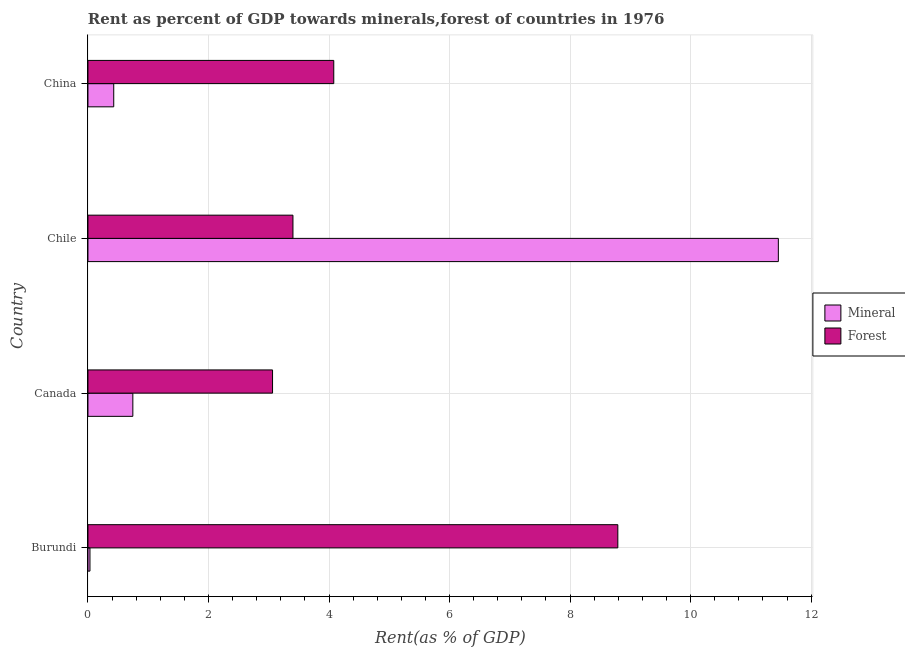How many different coloured bars are there?
Ensure brevity in your answer.  2. How many groups of bars are there?
Ensure brevity in your answer.  4. Are the number of bars per tick equal to the number of legend labels?
Keep it short and to the point. Yes. Are the number of bars on each tick of the Y-axis equal?
Your response must be concise. Yes. How many bars are there on the 2nd tick from the top?
Your response must be concise. 2. What is the label of the 3rd group of bars from the top?
Offer a terse response. Canada. What is the forest rent in Chile?
Your answer should be compact. 3.4. Across all countries, what is the maximum forest rent?
Make the answer very short. 8.79. Across all countries, what is the minimum forest rent?
Offer a terse response. 3.06. In which country was the mineral rent maximum?
Your answer should be very brief. Chile. What is the total mineral rent in the graph?
Your answer should be compact. 12.66. What is the difference between the mineral rent in Burundi and that in China?
Offer a terse response. -0.39. What is the difference between the mineral rent in China and the forest rent in Canada?
Keep it short and to the point. -2.64. What is the average mineral rent per country?
Keep it short and to the point. 3.17. What is the difference between the mineral rent and forest rent in Burundi?
Offer a terse response. -8.76. In how many countries, is the forest rent greater than 7.2 %?
Offer a terse response. 1. What is the ratio of the mineral rent in Chile to that in China?
Make the answer very short. 26.78. Is the forest rent in Burundi less than that in Chile?
Provide a succinct answer. No. Is the difference between the mineral rent in Chile and China greater than the difference between the forest rent in Chile and China?
Your response must be concise. Yes. What is the difference between the highest and the second highest mineral rent?
Your response must be concise. 10.71. What is the difference between the highest and the lowest mineral rent?
Give a very brief answer. 11.42. What does the 1st bar from the top in China represents?
Provide a succinct answer. Forest. What does the 2nd bar from the bottom in Chile represents?
Provide a short and direct response. Forest. How many bars are there?
Give a very brief answer. 8. How many countries are there in the graph?
Ensure brevity in your answer.  4. What is the difference between two consecutive major ticks on the X-axis?
Make the answer very short. 2. Are the values on the major ticks of X-axis written in scientific E-notation?
Offer a very short reply. No. Where does the legend appear in the graph?
Offer a terse response. Center right. How many legend labels are there?
Provide a succinct answer. 2. How are the legend labels stacked?
Ensure brevity in your answer.  Vertical. What is the title of the graph?
Give a very brief answer. Rent as percent of GDP towards minerals,forest of countries in 1976. What is the label or title of the X-axis?
Make the answer very short. Rent(as % of GDP). What is the Rent(as % of GDP) in Mineral in Burundi?
Your answer should be compact. 0.03. What is the Rent(as % of GDP) of Forest in Burundi?
Offer a very short reply. 8.79. What is the Rent(as % of GDP) of Mineral in Canada?
Your response must be concise. 0.74. What is the Rent(as % of GDP) of Forest in Canada?
Provide a short and direct response. 3.06. What is the Rent(as % of GDP) in Mineral in Chile?
Give a very brief answer. 11.46. What is the Rent(as % of GDP) of Forest in Chile?
Ensure brevity in your answer.  3.4. What is the Rent(as % of GDP) in Mineral in China?
Keep it short and to the point. 0.43. What is the Rent(as % of GDP) of Forest in China?
Your answer should be compact. 4.08. Across all countries, what is the maximum Rent(as % of GDP) in Mineral?
Give a very brief answer. 11.46. Across all countries, what is the maximum Rent(as % of GDP) of Forest?
Give a very brief answer. 8.79. Across all countries, what is the minimum Rent(as % of GDP) in Mineral?
Provide a short and direct response. 0.03. Across all countries, what is the minimum Rent(as % of GDP) of Forest?
Offer a terse response. 3.06. What is the total Rent(as % of GDP) in Mineral in the graph?
Offer a terse response. 12.66. What is the total Rent(as % of GDP) in Forest in the graph?
Offer a very short reply. 19.34. What is the difference between the Rent(as % of GDP) of Mineral in Burundi and that in Canada?
Provide a succinct answer. -0.71. What is the difference between the Rent(as % of GDP) in Forest in Burundi and that in Canada?
Offer a very short reply. 5.73. What is the difference between the Rent(as % of GDP) of Mineral in Burundi and that in Chile?
Offer a terse response. -11.42. What is the difference between the Rent(as % of GDP) of Forest in Burundi and that in Chile?
Offer a very short reply. 5.39. What is the difference between the Rent(as % of GDP) of Mineral in Burundi and that in China?
Provide a succinct answer. -0.39. What is the difference between the Rent(as % of GDP) of Forest in Burundi and that in China?
Your response must be concise. 4.71. What is the difference between the Rent(as % of GDP) of Mineral in Canada and that in Chile?
Make the answer very short. -10.71. What is the difference between the Rent(as % of GDP) of Forest in Canada and that in Chile?
Your response must be concise. -0.34. What is the difference between the Rent(as % of GDP) in Mineral in Canada and that in China?
Give a very brief answer. 0.32. What is the difference between the Rent(as % of GDP) in Forest in Canada and that in China?
Provide a succinct answer. -1.02. What is the difference between the Rent(as % of GDP) in Mineral in Chile and that in China?
Give a very brief answer. 11.03. What is the difference between the Rent(as % of GDP) in Forest in Chile and that in China?
Offer a terse response. -0.68. What is the difference between the Rent(as % of GDP) of Mineral in Burundi and the Rent(as % of GDP) of Forest in Canada?
Provide a succinct answer. -3.03. What is the difference between the Rent(as % of GDP) of Mineral in Burundi and the Rent(as % of GDP) of Forest in Chile?
Offer a very short reply. -3.37. What is the difference between the Rent(as % of GDP) of Mineral in Burundi and the Rent(as % of GDP) of Forest in China?
Keep it short and to the point. -4.05. What is the difference between the Rent(as % of GDP) in Mineral in Canada and the Rent(as % of GDP) in Forest in Chile?
Offer a very short reply. -2.66. What is the difference between the Rent(as % of GDP) in Mineral in Canada and the Rent(as % of GDP) in Forest in China?
Ensure brevity in your answer.  -3.33. What is the difference between the Rent(as % of GDP) in Mineral in Chile and the Rent(as % of GDP) in Forest in China?
Keep it short and to the point. 7.38. What is the average Rent(as % of GDP) in Mineral per country?
Give a very brief answer. 3.17. What is the average Rent(as % of GDP) in Forest per country?
Your response must be concise. 4.83. What is the difference between the Rent(as % of GDP) in Mineral and Rent(as % of GDP) in Forest in Burundi?
Offer a very short reply. -8.76. What is the difference between the Rent(as % of GDP) in Mineral and Rent(as % of GDP) in Forest in Canada?
Ensure brevity in your answer.  -2.32. What is the difference between the Rent(as % of GDP) of Mineral and Rent(as % of GDP) of Forest in Chile?
Provide a succinct answer. 8.05. What is the difference between the Rent(as % of GDP) of Mineral and Rent(as % of GDP) of Forest in China?
Your response must be concise. -3.65. What is the ratio of the Rent(as % of GDP) in Mineral in Burundi to that in Canada?
Offer a very short reply. 0.04. What is the ratio of the Rent(as % of GDP) of Forest in Burundi to that in Canada?
Ensure brevity in your answer.  2.87. What is the ratio of the Rent(as % of GDP) in Mineral in Burundi to that in Chile?
Keep it short and to the point. 0. What is the ratio of the Rent(as % of GDP) of Forest in Burundi to that in Chile?
Your response must be concise. 2.58. What is the ratio of the Rent(as % of GDP) of Mineral in Burundi to that in China?
Provide a succinct answer. 0.08. What is the ratio of the Rent(as % of GDP) of Forest in Burundi to that in China?
Provide a short and direct response. 2.16. What is the ratio of the Rent(as % of GDP) in Mineral in Canada to that in Chile?
Ensure brevity in your answer.  0.07. What is the ratio of the Rent(as % of GDP) in Forest in Canada to that in Chile?
Offer a terse response. 0.9. What is the ratio of the Rent(as % of GDP) of Mineral in Canada to that in China?
Provide a short and direct response. 1.74. What is the ratio of the Rent(as % of GDP) in Forest in Canada to that in China?
Keep it short and to the point. 0.75. What is the ratio of the Rent(as % of GDP) of Mineral in Chile to that in China?
Your response must be concise. 26.78. What is the ratio of the Rent(as % of GDP) in Forest in Chile to that in China?
Your answer should be compact. 0.83. What is the difference between the highest and the second highest Rent(as % of GDP) in Mineral?
Ensure brevity in your answer.  10.71. What is the difference between the highest and the second highest Rent(as % of GDP) of Forest?
Give a very brief answer. 4.71. What is the difference between the highest and the lowest Rent(as % of GDP) of Mineral?
Provide a short and direct response. 11.42. What is the difference between the highest and the lowest Rent(as % of GDP) in Forest?
Offer a very short reply. 5.73. 